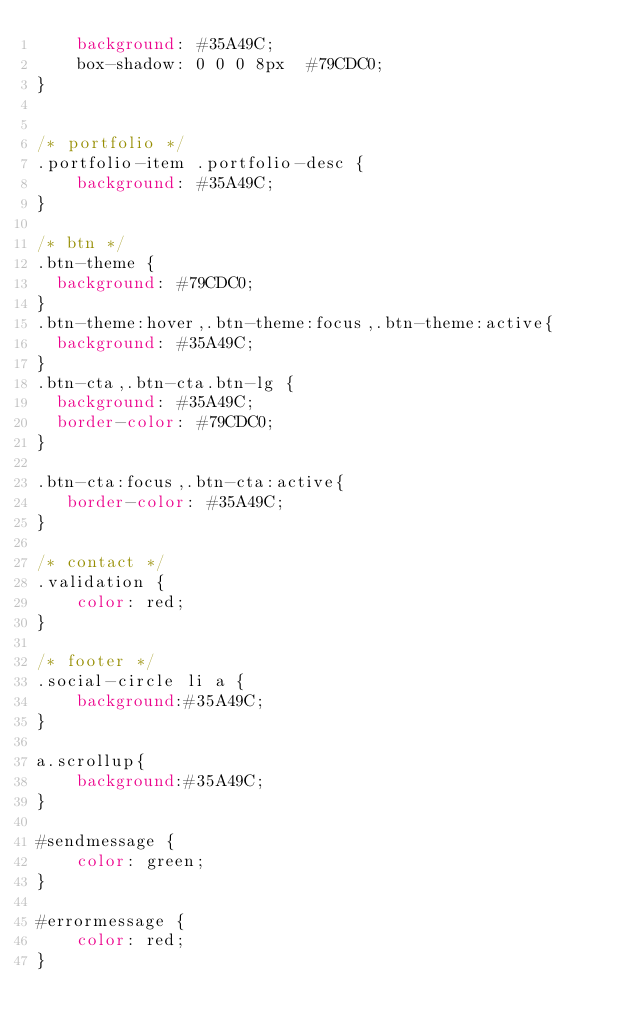<code> <loc_0><loc_0><loc_500><loc_500><_CSS_>	background: #35A49C;
	box-shadow: 0 0 0 8px  #79CDC0;
}


/* portfolio */
.portfolio-item .portfolio-desc {
	background: #35A49C;
}

/* btn */
.btn-theme {
  background: #79CDC0;
}
.btn-theme:hover,.btn-theme:focus,.btn-theme:active{
  background: #35A49C;
}
.btn-cta,.btn-cta.btn-lg {
  background: #35A49C;
  border-color: #79CDC0;
}

.btn-cta:focus,.btn-cta:active{
   border-color: #35A49C;
}

/* contact */
.validation {
	color: red;
}

/* footer */
.social-circle li a {
	background:#35A49C;
}

a.scrollup{
	background:#35A49C;
}

#sendmessage {
    color: green;
}

#errormessage {
    color: red;
}
</code> 